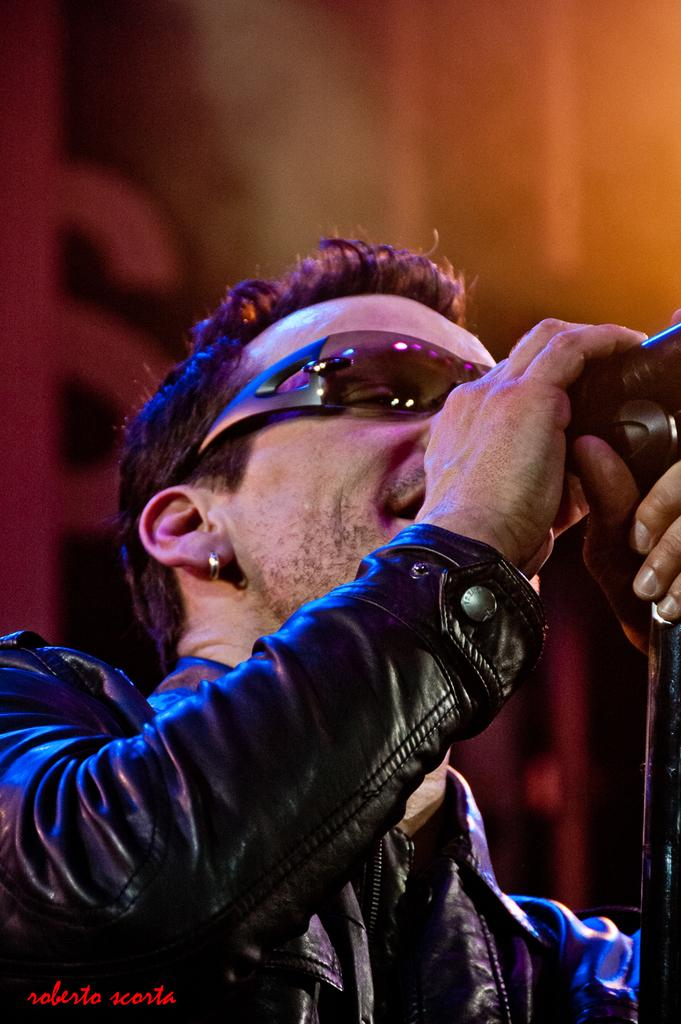What is the man in the image doing? The man is singing in the image. What object is the man holding while singing? The man is holding a microphone. Can you describe the man's attire in the image? The man is wearing a coat and goggles. What is the title of the book the man is reading in the image? There is no book present in the image, and the man is singing, not reading. 